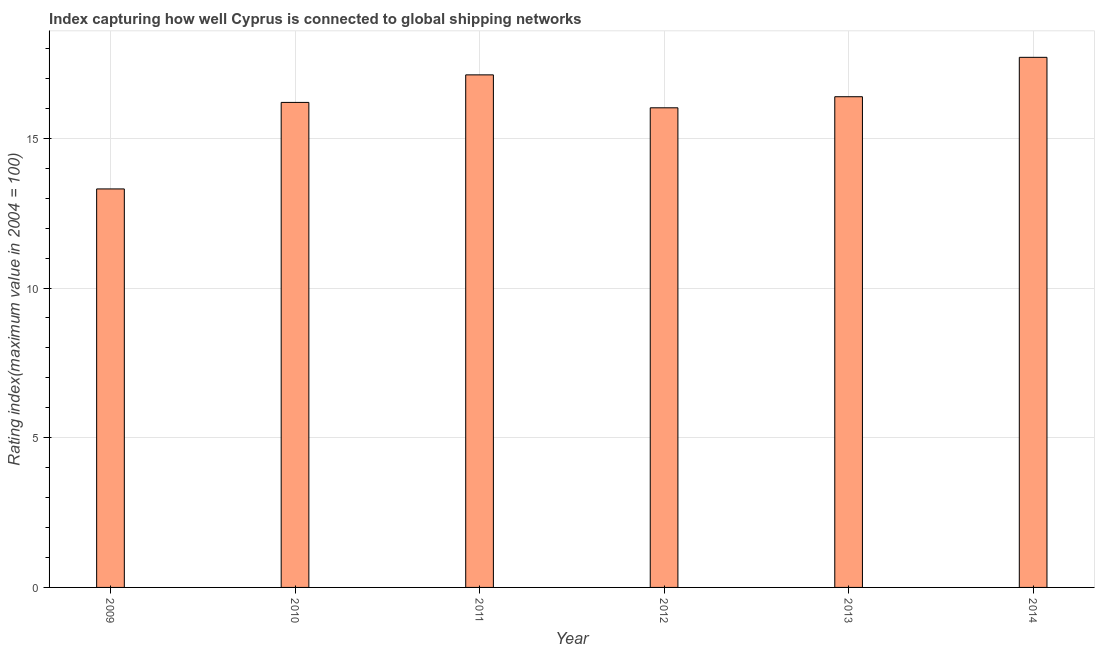What is the title of the graph?
Offer a terse response. Index capturing how well Cyprus is connected to global shipping networks. What is the label or title of the X-axis?
Keep it short and to the point. Year. What is the label or title of the Y-axis?
Give a very brief answer. Rating index(maximum value in 2004 = 100). What is the liner shipping connectivity index in 2013?
Make the answer very short. 16.39. Across all years, what is the maximum liner shipping connectivity index?
Offer a very short reply. 17.71. Across all years, what is the minimum liner shipping connectivity index?
Offer a terse response. 13.31. In which year was the liner shipping connectivity index maximum?
Your answer should be very brief. 2014. In which year was the liner shipping connectivity index minimum?
Offer a very short reply. 2009. What is the sum of the liner shipping connectivity index?
Provide a short and direct response. 96.75. What is the difference between the liner shipping connectivity index in 2009 and 2011?
Your answer should be very brief. -3.81. What is the average liner shipping connectivity index per year?
Keep it short and to the point. 16.12. What is the median liner shipping connectivity index?
Provide a succinct answer. 16.3. In how many years, is the liner shipping connectivity index greater than 7 ?
Your answer should be compact. 6. What is the ratio of the liner shipping connectivity index in 2009 to that in 2011?
Offer a terse response. 0.78. Is the difference between the liner shipping connectivity index in 2011 and 2014 greater than the difference between any two years?
Keep it short and to the point. No. What is the difference between the highest and the second highest liner shipping connectivity index?
Your answer should be very brief. 0.59. Is the sum of the liner shipping connectivity index in 2009 and 2013 greater than the maximum liner shipping connectivity index across all years?
Offer a very short reply. Yes. What is the difference between the highest and the lowest liner shipping connectivity index?
Give a very brief answer. 4.4. In how many years, is the liner shipping connectivity index greater than the average liner shipping connectivity index taken over all years?
Offer a very short reply. 4. What is the Rating index(maximum value in 2004 = 100) of 2009?
Keep it short and to the point. 13.31. What is the Rating index(maximum value in 2004 = 100) of 2010?
Make the answer very short. 16.2. What is the Rating index(maximum value in 2004 = 100) in 2011?
Provide a short and direct response. 17.12. What is the Rating index(maximum value in 2004 = 100) of 2012?
Your answer should be compact. 16.02. What is the Rating index(maximum value in 2004 = 100) of 2013?
Ensure brevity in your answer.  16.39. What is the Rating index(maximum value in 2004 = 100) of 2014?
Keep it short and to the point. 17.71. What is the difference between the Rating index(maximum value in 2004 = 100) in 2009 and 2010?
Keep it short and to the point. -2.89. What is the difference between the Rating index(maximum value in 2004 = 100) in 2009 and 2011?
Offer a terse response. -3.81. What is the difference between the Rating index(maximum value in 2004 = 100) in 2009 and 2012?
Keep it short and to the point. -2.71. What is the difference between the Rating index(maximum value in 2004 = 100) in 2009 and 2013?
Give a very brief answer. -3.08. What is the difference between the Rating index(maximum value in 2004 = 100) in 2009 and 2014?
Your response must be concise. -4.4. What is the difference between the Rating index(maximum value in 2004 = 100) in 2010 and 2011?
Your answer should be compact. -0.92. What is the difference between the Rating index(maximum value in 2004 = 100) in 2010 and 2012?
Offer a very short reply. 0.18. What is the difference between the Rating index(maximum value in 2004 = 100) in 2010 and 2013?
Make the answer very short. -0.19. What is the difference between the Rating index(maximum value in 2004 = 100) in 2010 and 2014?
Your answer should be very brief. -1.51. What is the difference between the Rating index(maximum value in 2004 = 100) in 2011 and 2012?
Ensure brevity in your answer.  1.1. What is the difference between the Rating index(maximum value in 2004 = 100) in 2011 and 2013?
Keep it short and to the point. 0.73. What is the difference between the Rating index(maximum value in 2004 = 100) in 2011 and 2014?
Offer a terse response. -0.59. What is the difference between the Rating index(maximum value in 2004 = 100) in 2012 and 2013?
Ensure brevity in your answer.  -0.37. What is the difference between the Rating index(maximum value in 2004 = 100) in 2012 and 2014?
Offer a very short reply. -1.69. What is the difference between the Rating index(maximum value in 2004 = 100) in 2013 and 2014?
Offer a terse response. -1.32. What is the ratio of the Rating index(maximum value in 2004 = 100) in 2009 to that in 2010?
Your answer should be compact. 0.82. What is the ratio of the Rating index(maximum value in 2004 = 100) in 2009 to that in 2011?
Give a very brief answer. 0.78. What is the ratio of the Rating index(maximum value in 2004 = 100) in 2009 to that in 2012?
Give a very brief answer. 0.83. What is the ratio of the Rating index(maximum value in 2004 = 100) in 2009 to that in 2013?
Give a very brief answer. 0.81. What is the ratio of the Rating index(maximum value in 2004 = 100) in 2009 to that in 2014?
Give a very brief answer. 0.75. What is the ratio of the Rating index(maximum value in 2004 = 100) in 2010 to that in 2011?
Provide a succinct answer. 0.95. What is the ratio of the Rating index(maximum value in 2004 = 100) in 2010 to that in 2012?
Your response must be concise. 1.01. What is the ratio of the Rating index(maximum value in 2004 = 100) in 2010 to that in 2014?
Offer a terse response. 0.92. What is the ratio of the Rating index(maximum value in 2004 = 100) in 2011 to that in 2012?
Give a very brief answer. 1.07. What is the ratio of the Rating index(maximum value in 2004 = 100) in 2011 to that in 2013?
Provide a succinct answer. 1.04. What is the ratio of the Rating index(maximum value in 2004 = 100) in 2012 to that in 2013?
Your answer should be very brief. 0.98. What is the ratio of the Rating index(maximum value in 2004 = 100) in 2012 to that in 2014?
Provide a short and direct response. 0.91. What is the ratio of the Rating index(maximum value in 2004 = 100) in 2013 to that in 2014?
Offer a very short reply. 0.93. 